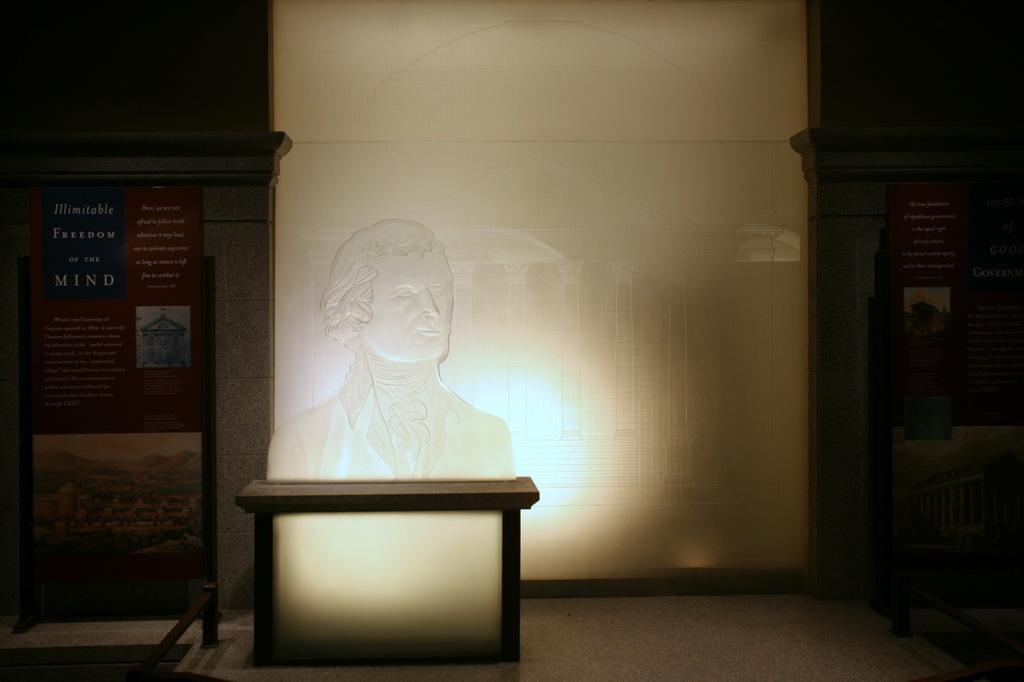How would you summarize this image in a sentence or two? In the middle of the picture, we see the glass statue of the man, which is placed on the table. On the left side, we see a stand and a board in brown and blue color with some text written on it. On the right side, we see a stand and a board in brown color with some text written on it. In the middle, we see a glass and behind that, we see a wall in white wall. 